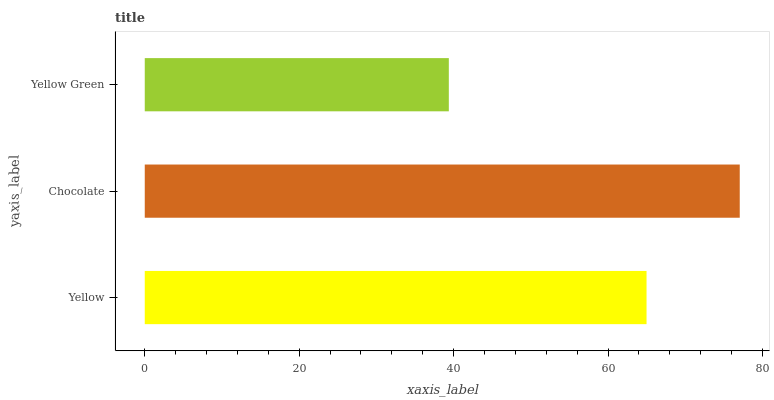Is Yellow Green the minimum?
Answer yes or no. Yes. Is Chocolate the maximum?
Answer yes or no. Yes. Is Chocolate the minimum?
Answer yes or no. No. Is Yellow Green the maximum?
Answer yes or no. No. Is Chocolate greater than Yellow Green?
Answer yes or no. Yes. Is Yellow Green less than Chocolate?
Answer yes or no. Yes. Is Yellow Green greater than Chocolate?
Answer yes or no. No. Is Chocolate less than Yellow Green?
Answer yes or no. No. Is Yellow the high median?
Answer yes or no. Yes. Is Yellow the low median?
Answer yes or no. Yes. Is Chocolate the high median?
Answer yes or no. No. Is Yellow Green the low median?
Answer yes or no. No. 